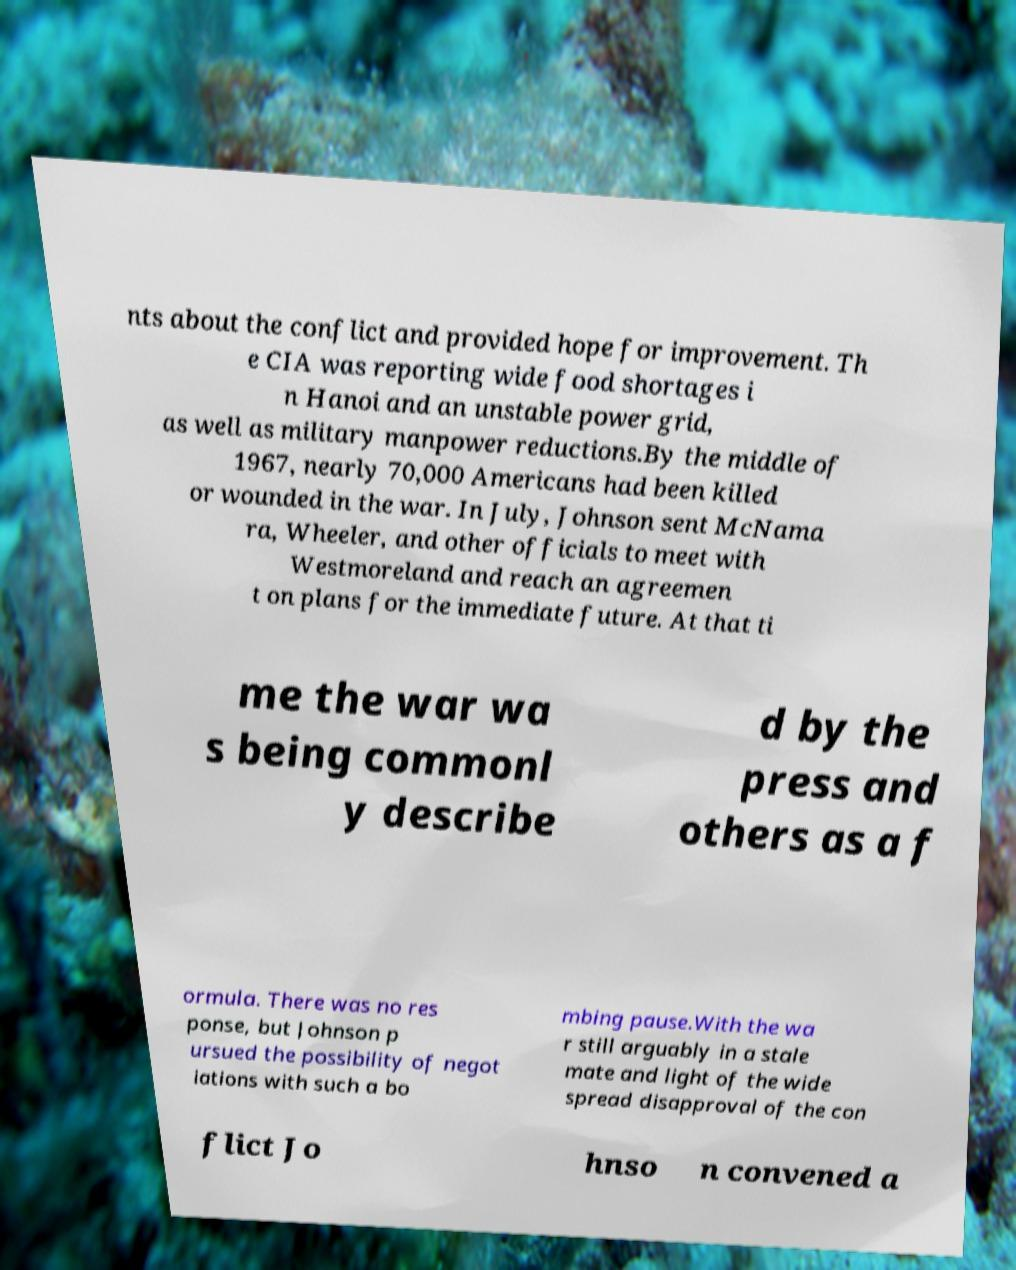Can you accurately transcribe the text from the provided image for me? nts about the conflict and provided hope for improvement. Th e CIA was reporting wide food shortages i n Hanoi and an unstable power grid, as well as military manpower reductions.By the middle of 1967, nearly 70,000 Americans had been killed or wounded in the war. In July, Johnson sent McNama ra, Wheeler, and other officials to meet with Westmoreland and reach an agreemen t on plans for the immediate future. At that ti me the war wa s being commonl y describe d by the press and others as a f ormula. There was no res ponse, but Johnson p ursued the possibility of negot iations with such a bo mbing pause.With the wa r still arguably in a stale mate and light of the wide spread disapproval of the con flict Jo hnso n convened a 